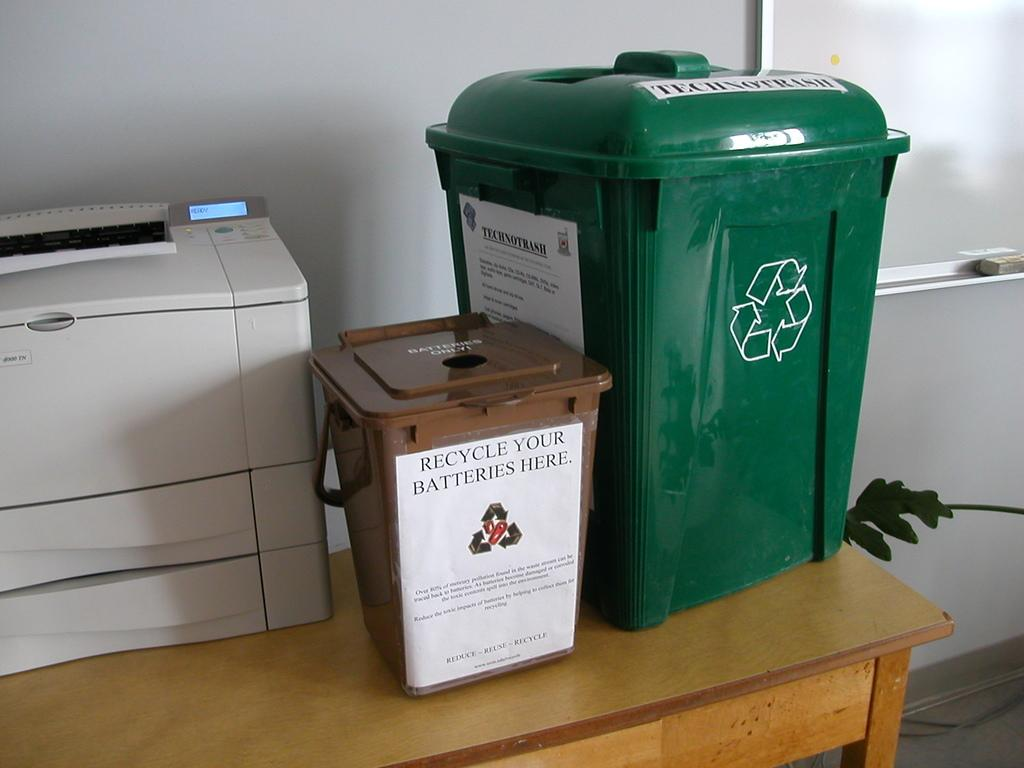<image>
Share a concise interpretation of the image provided. two recycling bins read Recycle HERE are on a table 